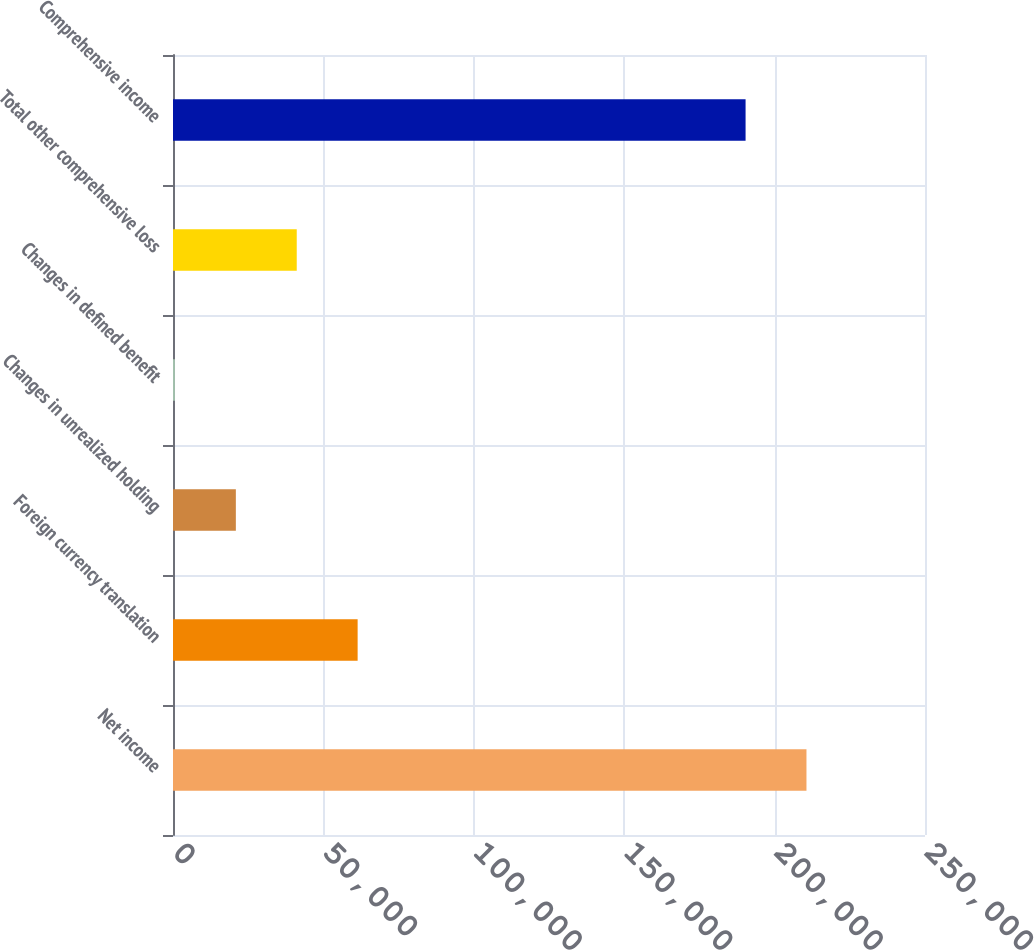<chart> <loc_0><loc_0><loc_500><loc_500><bar_chart><fcel>Net income<fcel>Foreign currency translation<fcel>Changes in unrealized holding<fcel>Changes in defined benefit<fcel>Total other comprehensive loss<fcel>Comprehensive income<nl><fcel>210595<fcel>61380.8<fcel>20893.6<fcel>650<fcel>41137.2<fcel>190351<nl></chart> 